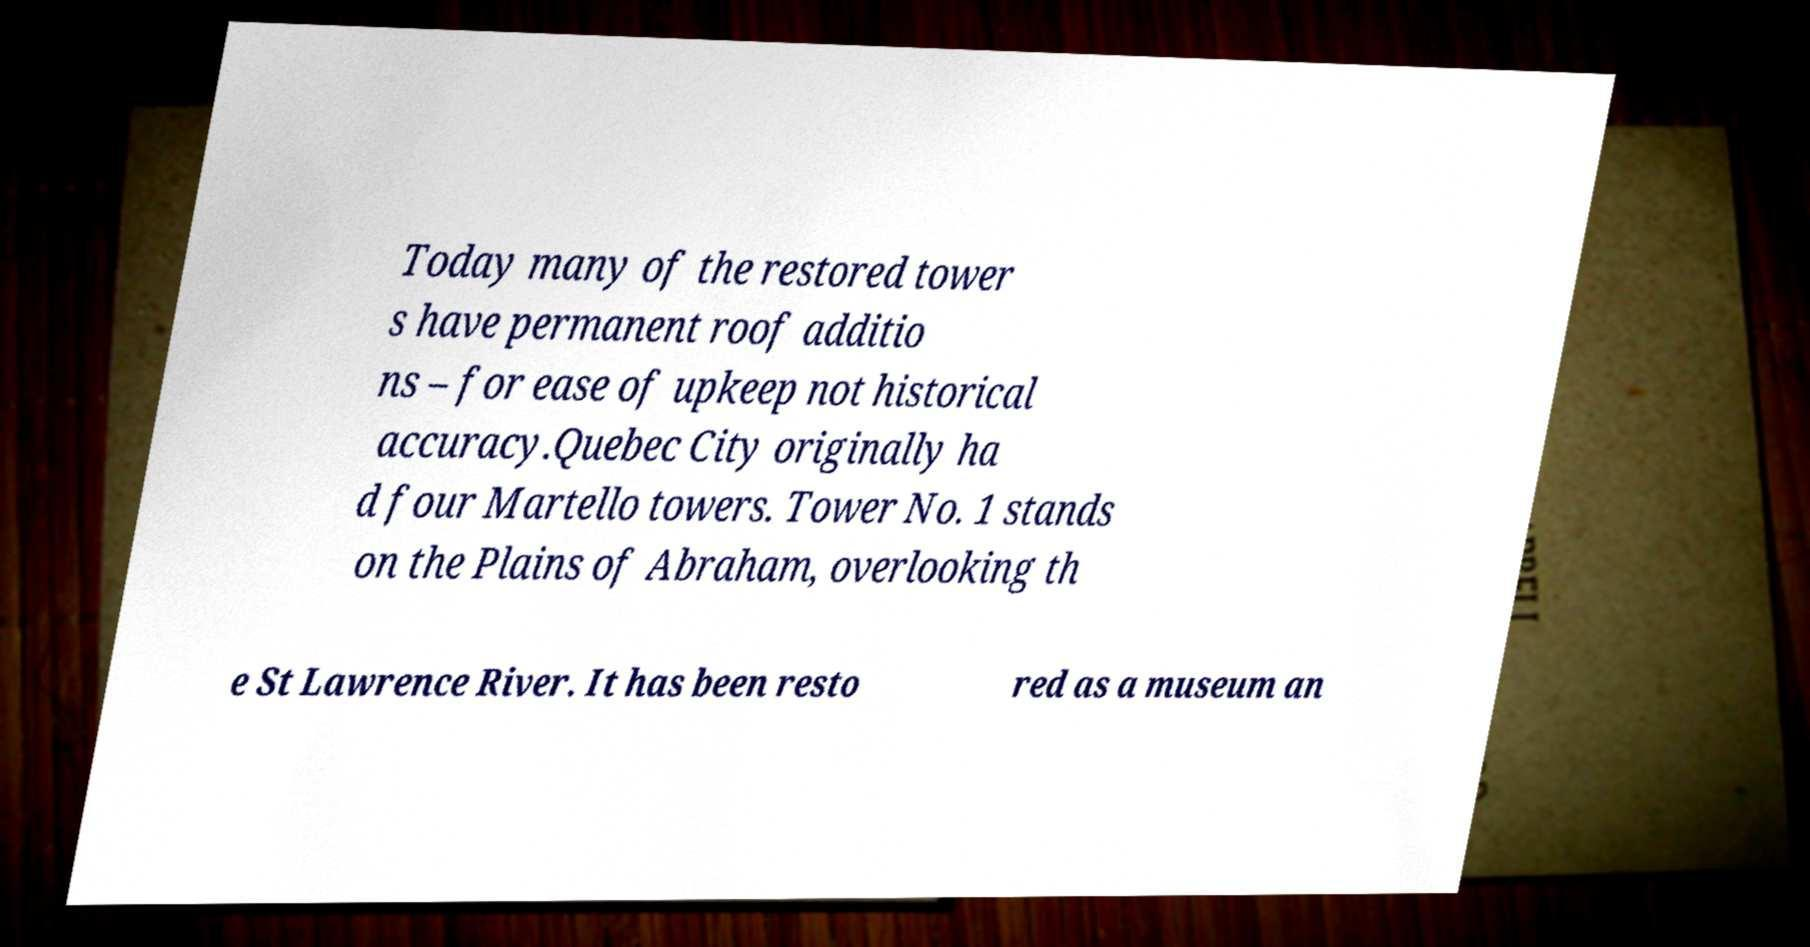I need the written content from this picture converted into text. Can you do that? Today many of the restored tower s have permanent roof additio ns – for ease of upkeep not historical accuracy.Quebec City originally ha d four Martello towers. Tower No. 1 stands on the Plains of Abraham, overlooking th e St Lawrence River. It has been resto red as a museum an 